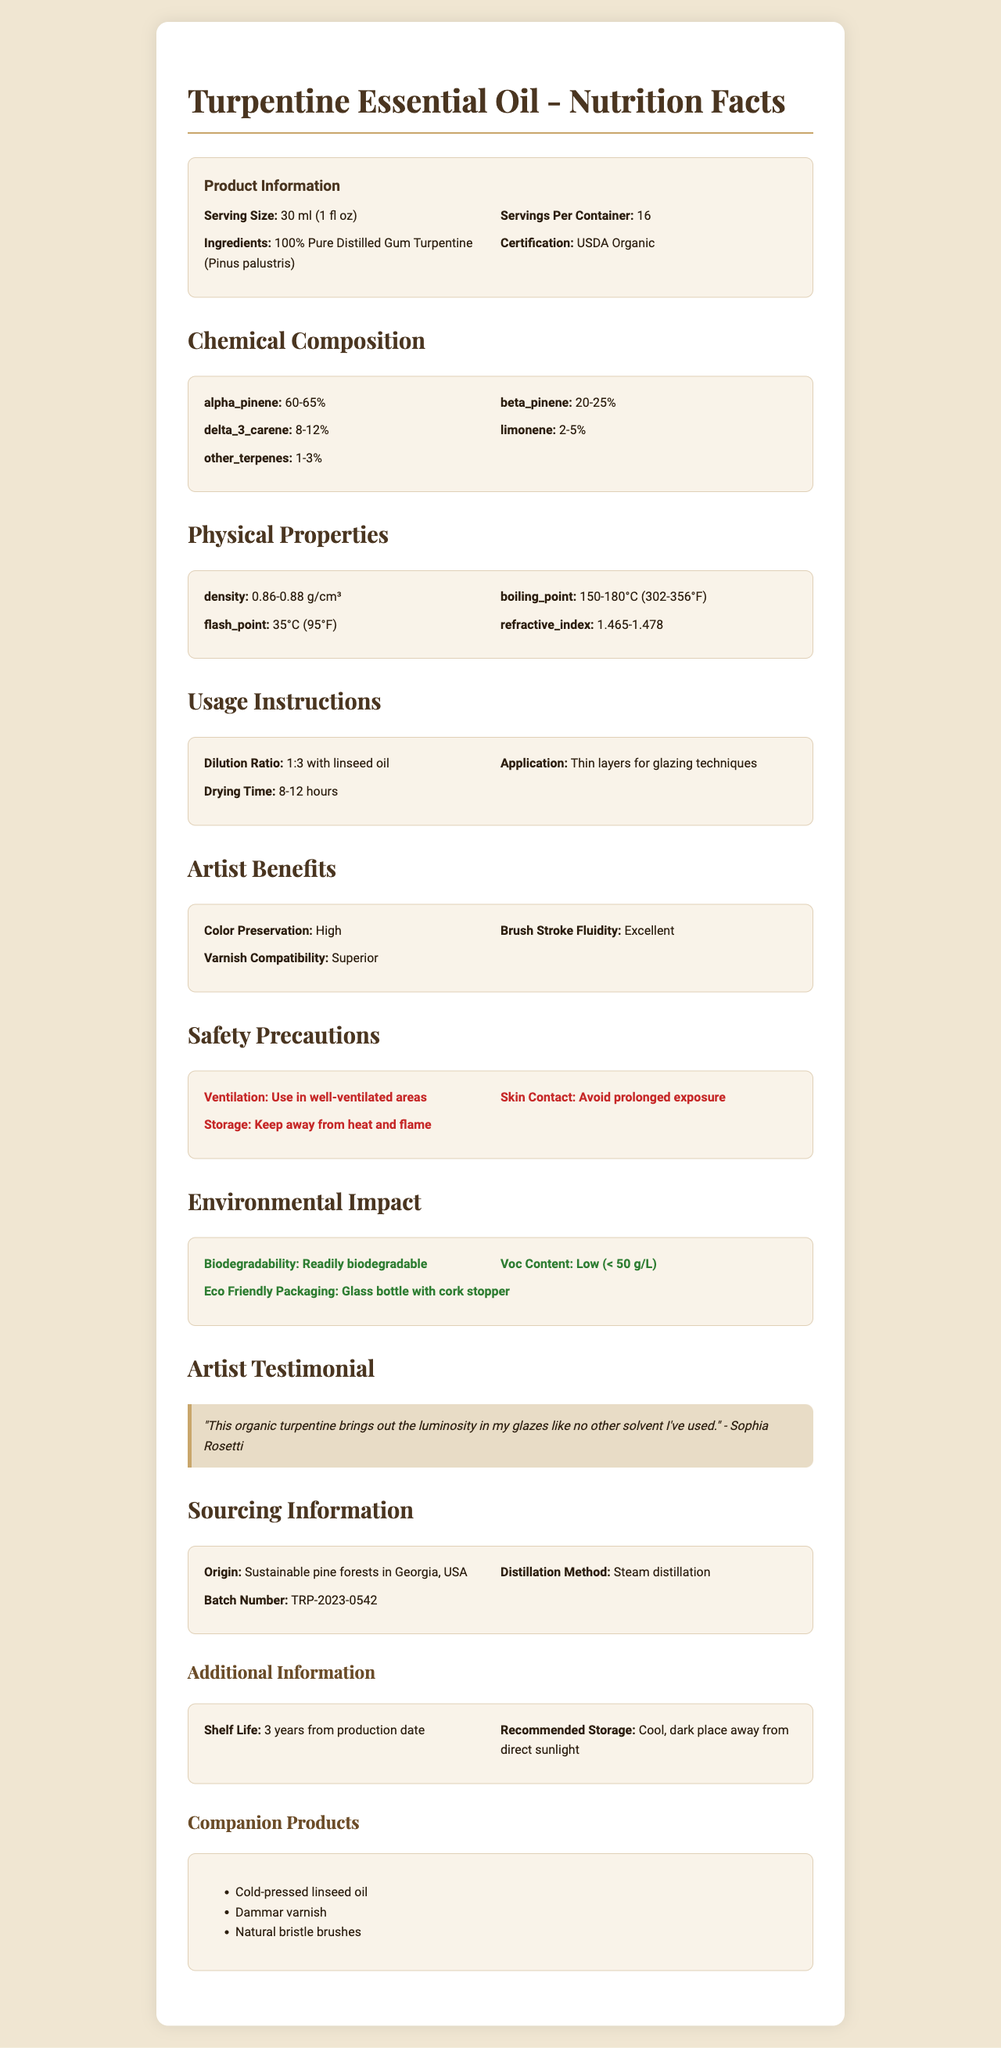what is the product name? The product name is explicitly mentioned at the beginning and in the title of the document.
Answer: Turpentine Essential Oil what is the serving size of the Turpentine Essential Oil? The serving size is listed in the "Product Information" section.
Answer: 30 ml (1 fl oz) what are the main ingredients in this product? The ingredients are listed in the "Product Information" section under "Ingredients".
Answer: 100% Pure Distilled Gum Turpentine (Pinus palustris) what is the density range of this product? The density range is listed under the "Physical Properties" section.
Answer: 0.86-0.88 g/cm³ which percentage range does alpha-pinene fall into? The percentage range for alpha-pinene is provided in the "Chemical Composition" section.
Answer: 60-65% what is the boiling point range of this product? The boiling point range is given in the "Physical Properties" section.
Answer: 150-180°C (302-356°F) what is the recommended dilution ratio with linseed oil? This information is listed under "Usage Instructions" in the "Dilution Ratio" section.
Answer: 1:3 how long is the drying time for this product? The drying time is provided under "Usage Instructions".
Answer: 8-12 hours what is the suggested storage condition? The recommended storage is mentioned at the end of the document under "Additional Information".
Answer: Cool, dark place away from direct sunlight which chemicals are part of the chemical composition of the product? A. Alpha-pinene B. Ethanol C. Beta-pinene D. Delta-3-carene E. Benzene The chemicals listed under "Chemical Composition" include alpha-pinene, beta-pinene, delta-3-carene, limonene, and other terpenes.
Answer: A, C, D what are the physical properties listed in the document? A. Density B. Flash Point C. Viscosity D. Boiling Point E. Refractive Index The physical properties listed include density, boiling point, flash point, and refractive index.
Answer: A, B, D, E is the product USDA Organic certified? The product's organic certification is mentioned under "Product Information".
Answer: Yes what benefits does the product provide to artists? The benefits are listed in the "Artist Benefits" section.
Answer: High color preservation, excellent brush stroke fluidity, superior varnish compatibility describe the major sections covered in the document. The document provides comprehensive details on the Turpentine Essential Oil, including its attributes, usage, and benefits.
Answer: The document covers product information, chemical composition, physical properties, usage instructions, artist benefits, safety precautions, environmental impact, artist testimonial, sourcing information, shelf life, recommended storage, and companion products. what is the batch number of the product? The batch number is provided in the "Sourcing Information" section.
Answer: TRP-2023-0542 what is the exact boiling point of the product? The boiling point is given as a range (150-180°C), not an exact value, so the exact boiling point cannot be determined.
Answer: Cannot be determined who gave the artist testimonial in the document? The testimonial is quoted by Sophia Rosetti, as mentioned under "Artist Testimonial".
Answer: Sophia Rosetti where is the origin of the product? The origin is stated in the "Sourcing Information" section.
Answer: Sustainable pine forests in Georgia, USA which companion product is suggested for use with Turpentine Essential Oil? The suggested companion products are listed in the "Companion Products" section.
Answer: Cold-pressed linseed oil, Dammar varnish, Natural bristle brushes 